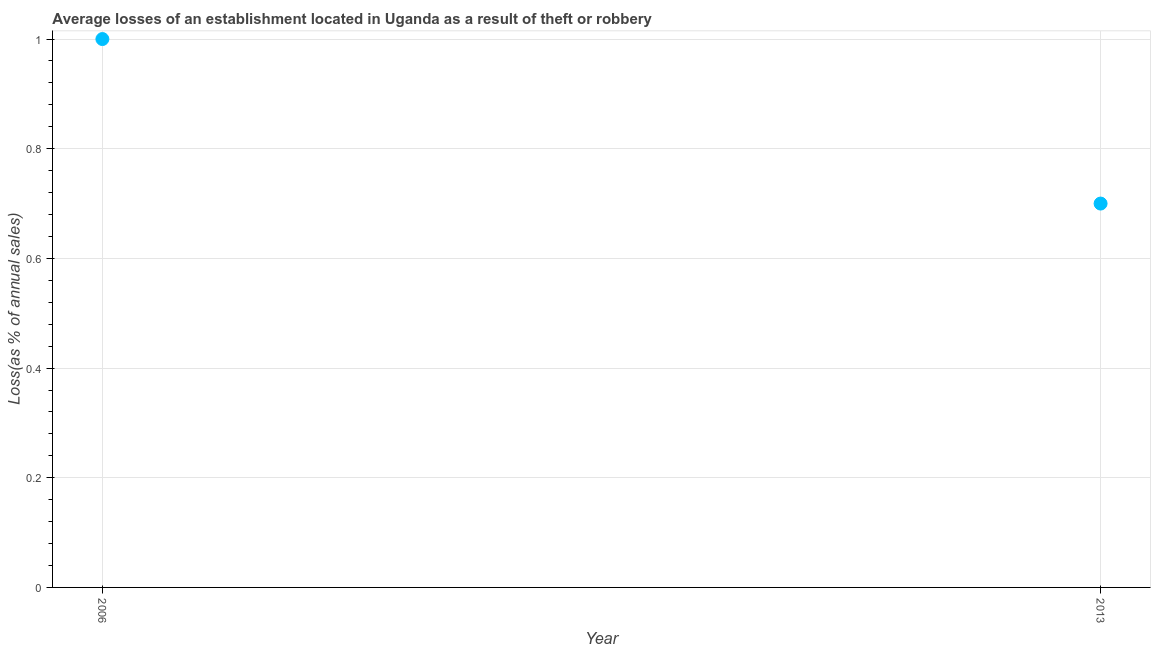What is the losses due to theft in 2013?
Offer a very short reply. 0.7. In which year was the losses due to theft maximum?
Make the answer very short. 2006. What is the sum of the losses due to theft?
Keep it short and to the point. 1.7. What is the difference between the losses due to theft in 2006 and 2013?
Your answer should be compact. 0.3. What is the median losses due to theft?
Ensure brevity in your answer.  0.85. What is the ratio of the losses due to theft in 2006 to that in 2013?
Make the answer very short. 1.43. Is the losses due to theft in 2006 less than that in 2013?
Your answer should be compact. No. In how many years, is the losses due to theft greater than the average losses due to theft taken over all years?
Your answer should be very brief. 1. What is the difference between two consecutive major ticks on the Y-axis?
Give a very brief answer. 0.2. Does the graph contain grids?
Your answer should be compact. Yes. What is the title of the graph?
Your answer should be very brief. Average losses of an establishment located in Uganda as a result of theft or robbery. What is the label or title of the X-axis?
Your answer should be very brief. Year. What is the label or title of the Y-axis?
Keep it short and to the point. Loss(as % of annual sales). What is the Loss(as % of annual sales) in 2013?
Provide a succinct answer. 0.7. What is the ratio of the Loss(as % of annual sales) in 2006 to that in 2013?
Give a very brief answer. 1.43. 